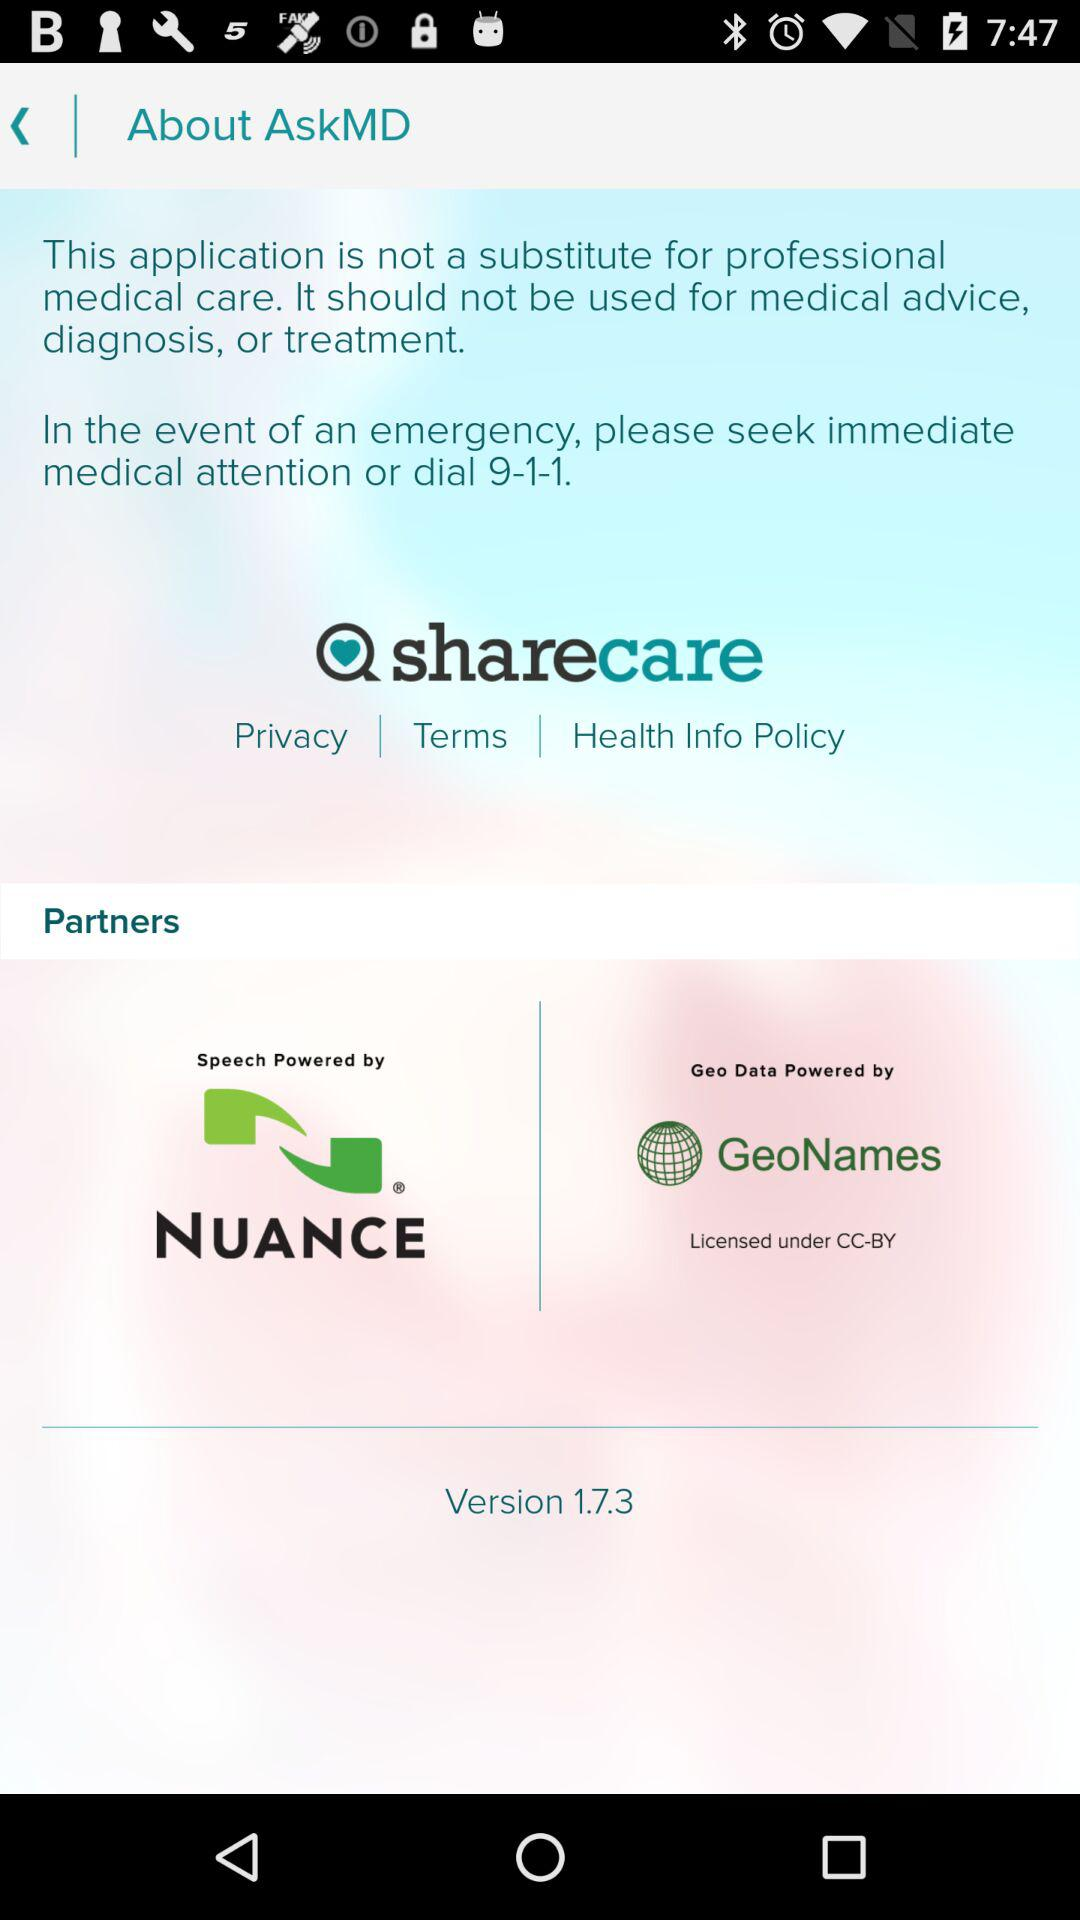What are the names of the partners of the application? The names of the partners are "NUANCE" and "GeoNames". 